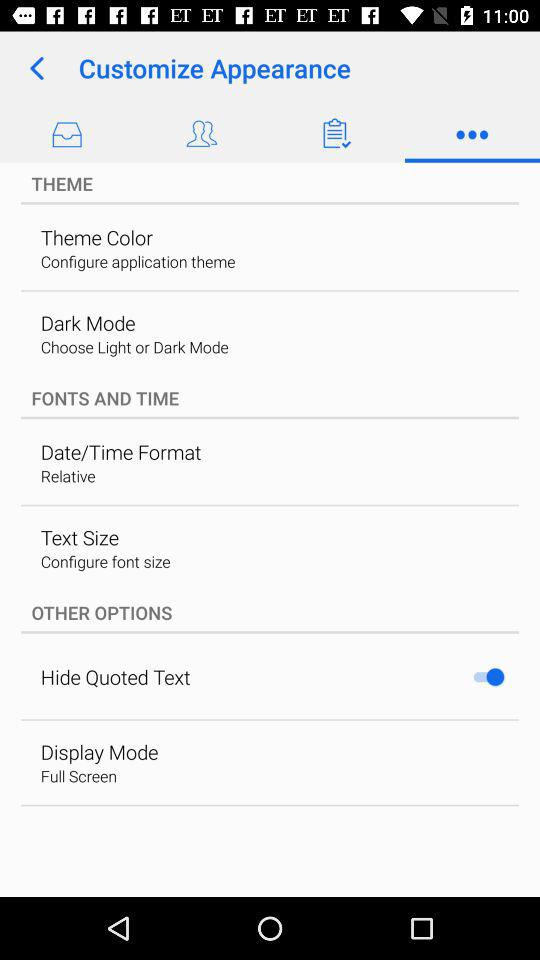What is the status of the "Hide Quoted Text" setting? The status is "on". 